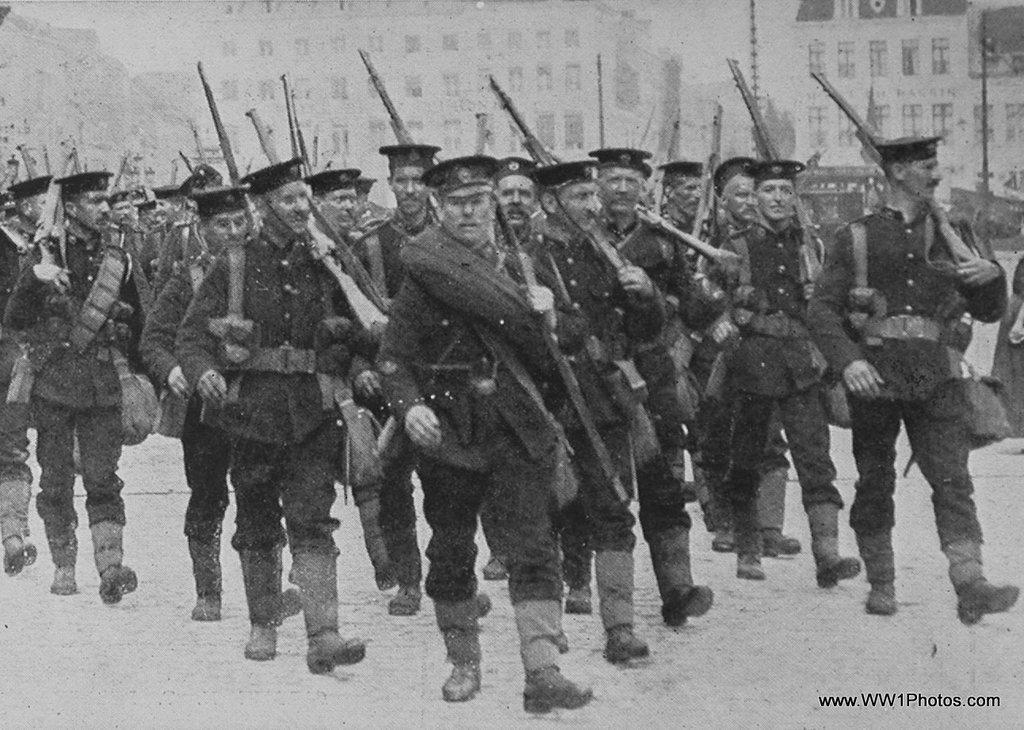What are the people in the image doing? The people in the image are walking. What are the people holding while walking? The people are holding guns. What else are the people carrying in the image? The people are carrying bags. What can be seen in the background of the image? There are buildings and poles in the background of the image. Where is the text located in the image? The text is in the bottom right side of the image. What type of dirt can be seen on the people's shoes in the image? There is no dirt visible on the people's shoes in the image. How fast are the people running in the image? The people are not running in the image; they are walking. 